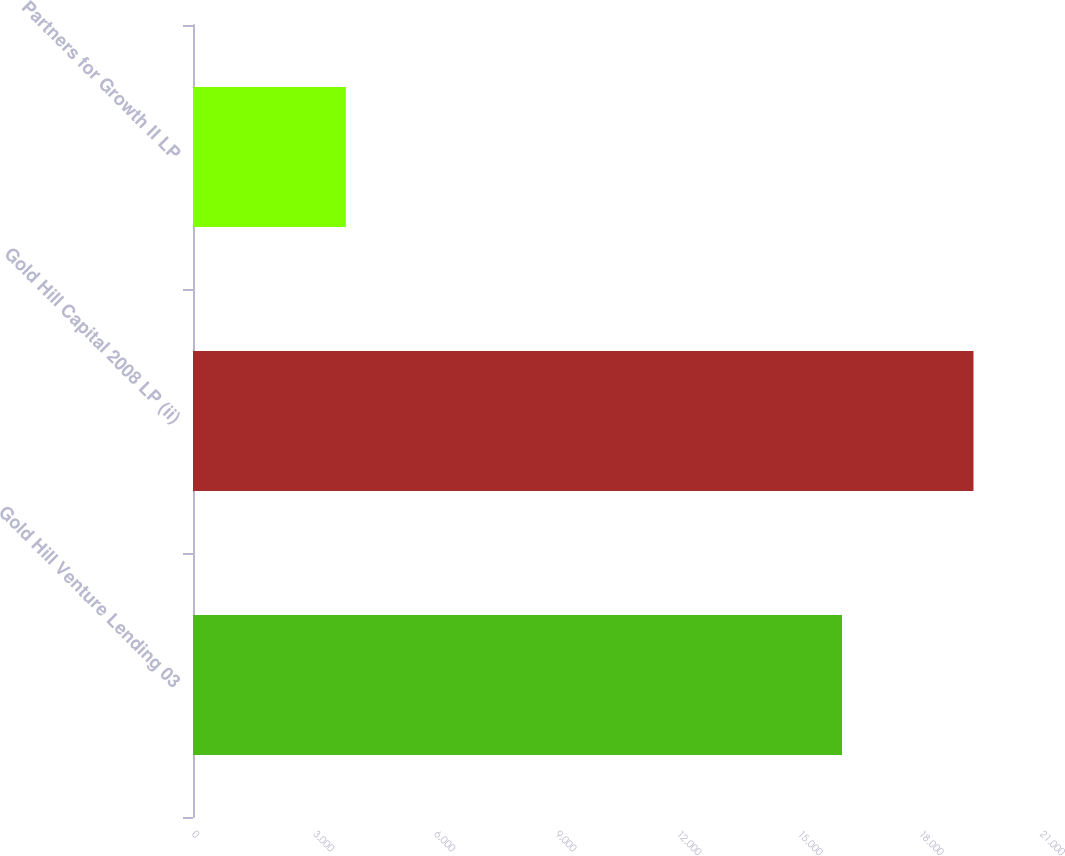Convert chart. <chart><loc_0><loc_0><loc_500><loc_500><bar_chart><fcel>Gold Hill Venture Lending 03<fcel>Gold Hill Capital 2008 LP (ii)<fcel>Partners for Growth II LP<nl><fcel>16072<fcel>19328<fcel>3785<nl></chart> 